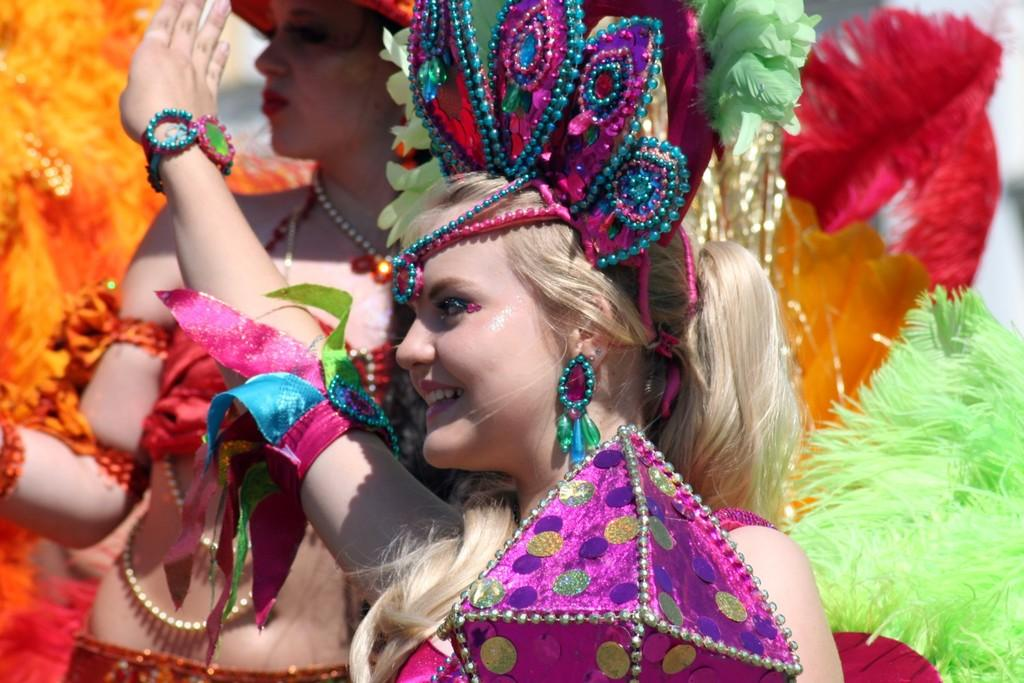Who can be seen in the image? There are people in the image. What are the people wearing? The people are wearing costumes. Can you describe the woman in the middle of the image? The woman in the middle of the image is wearing a costume and smiling. What song is the woman singing in the image? There is no indication in the image that the woman is singing, so it cannot be determined from the picture. 